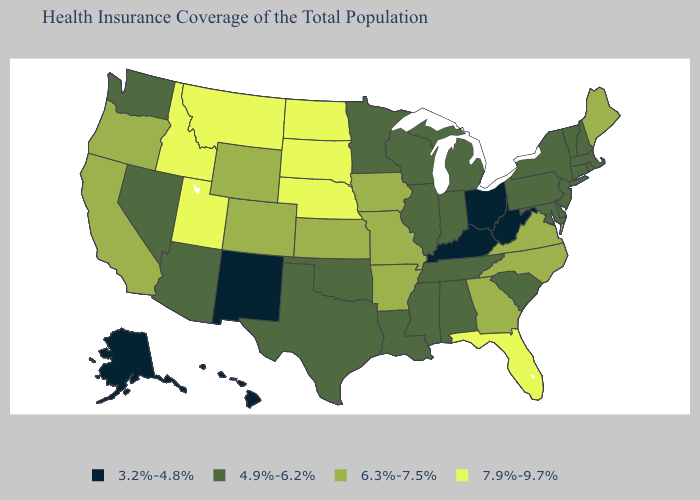What is the value of Illinois?
Short answer required. 4.9%-6.2%. What is the highest value in states that border Alabama?
Give a very brief answer. 7.9%-9.7%. What is the value of Alaska?
Answer briefly. 3.2%-4.8%. Does Kansas have the lowest value in the USA?
Write a very short answer. No. Name the states that have a value in the range 3.2%-4.8%?
Quick response, please. Alaska, Hawaii, Kentucky, New Mexico, Ohio, West Virginia. Is the legend a continuous bar?
Concise answer only. No. Name the states that have a value in the range 3.2%-4.8%?
Short answer required. Alaska, Hawaii, Kentucky, New Mexico, Ohio, West Virginia. Name the states that have a value in the range 7.9%-9.7%?
Answer briefly. Florida, Idaho, Montana, Nebraska, North Dakota, South Dakota, Utah. Name the states that have a value in the range 7.9%-9.7%?
Answer briefly. Florida, Idaho, Montana, Nebraska, North Dakota, South Dakota, Utah. How many symbols are there in the legend?
Write a very short answer. 4. Name the states that have a value in the range 3.2%-4.8%?
Be succinct. Alaska, Hawaii, Kentucky, New Mexico, Ohio, West Virginia. Name the states that have a value in the range 6.3%-7.5%?
Keep it brief. Arkansas, California, Colorado, Georgia, Iowa, Kansas, Maine, Missouri, North Carolina, Oregon, Virginia, Wyoming. What is the highest value in the USA?
Concise answer only. 7.9%-9.7%. Which states have the lowest value in the Northeast?
Write a very short answer. Connecticut, Massachusetts, New Hampshire, New Jersey, New York, Pennsylvania, Rhode Island, Vermont. Does Rhode Island have the same value as Wisconsin?
Give a very brief answer. Yes. 